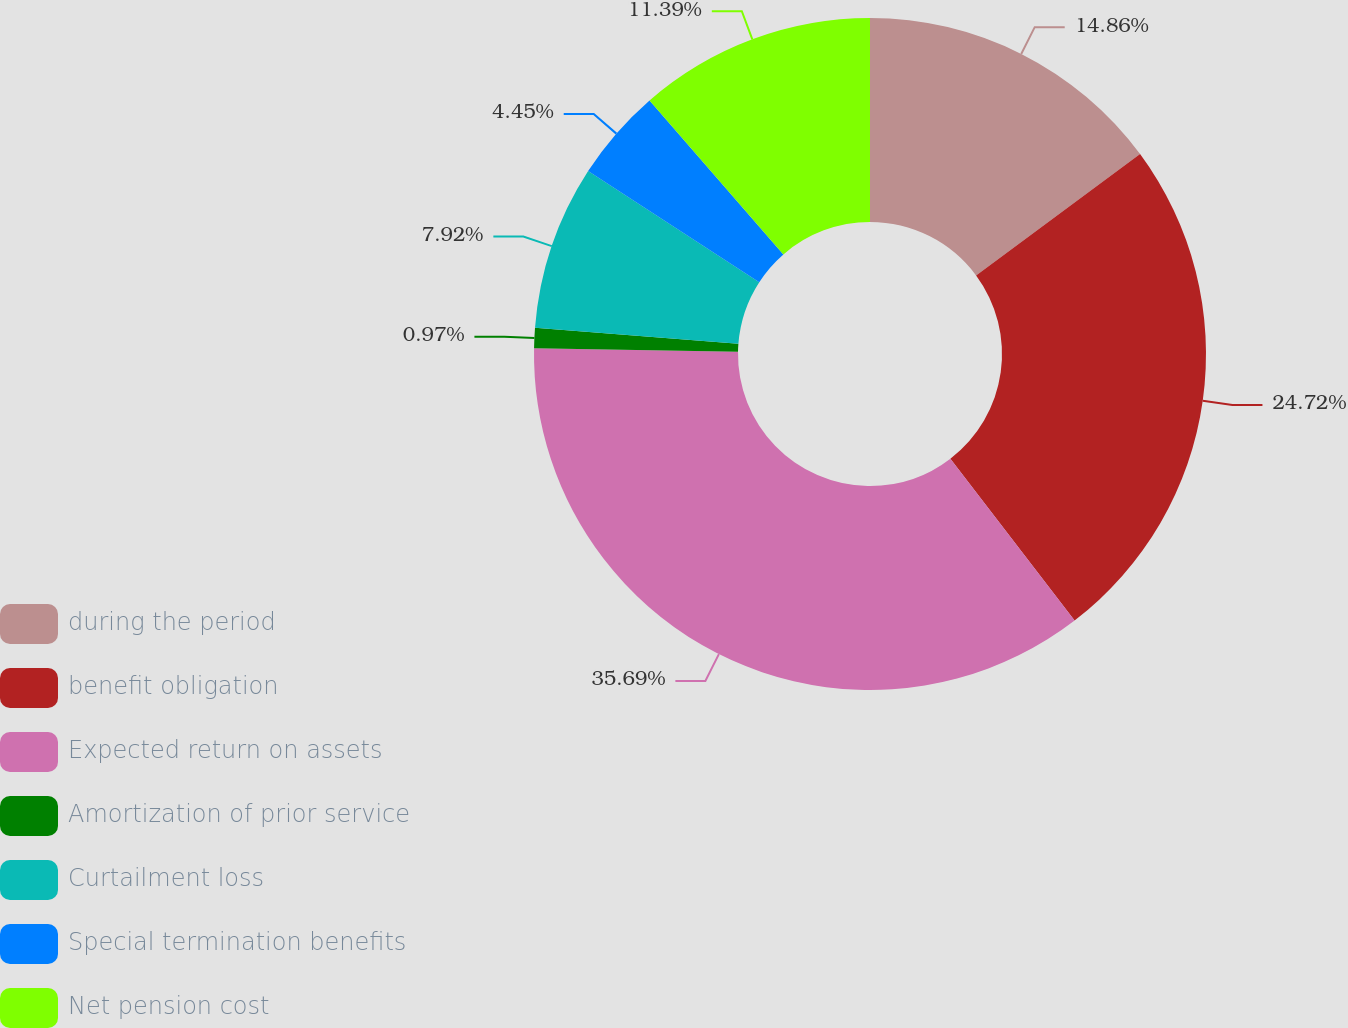Convert chart. <chart><loc_0><loc_0><loc_500><loc_500><pie_chart><fcel>during the period<fcel>benefit obligation<fcel>Expected return on assets<fcel>Amortization of prior service<fcel>Curtailment loss<fcel>Special termination benefits<fcel>Net pension cost<nl><fcel>14.86%<fcel>24.72%<fcel>35.69%<fcel>0.97%<fcel>7.92%<fcel>4.45%<fcel>11.39%<nl></chart> 